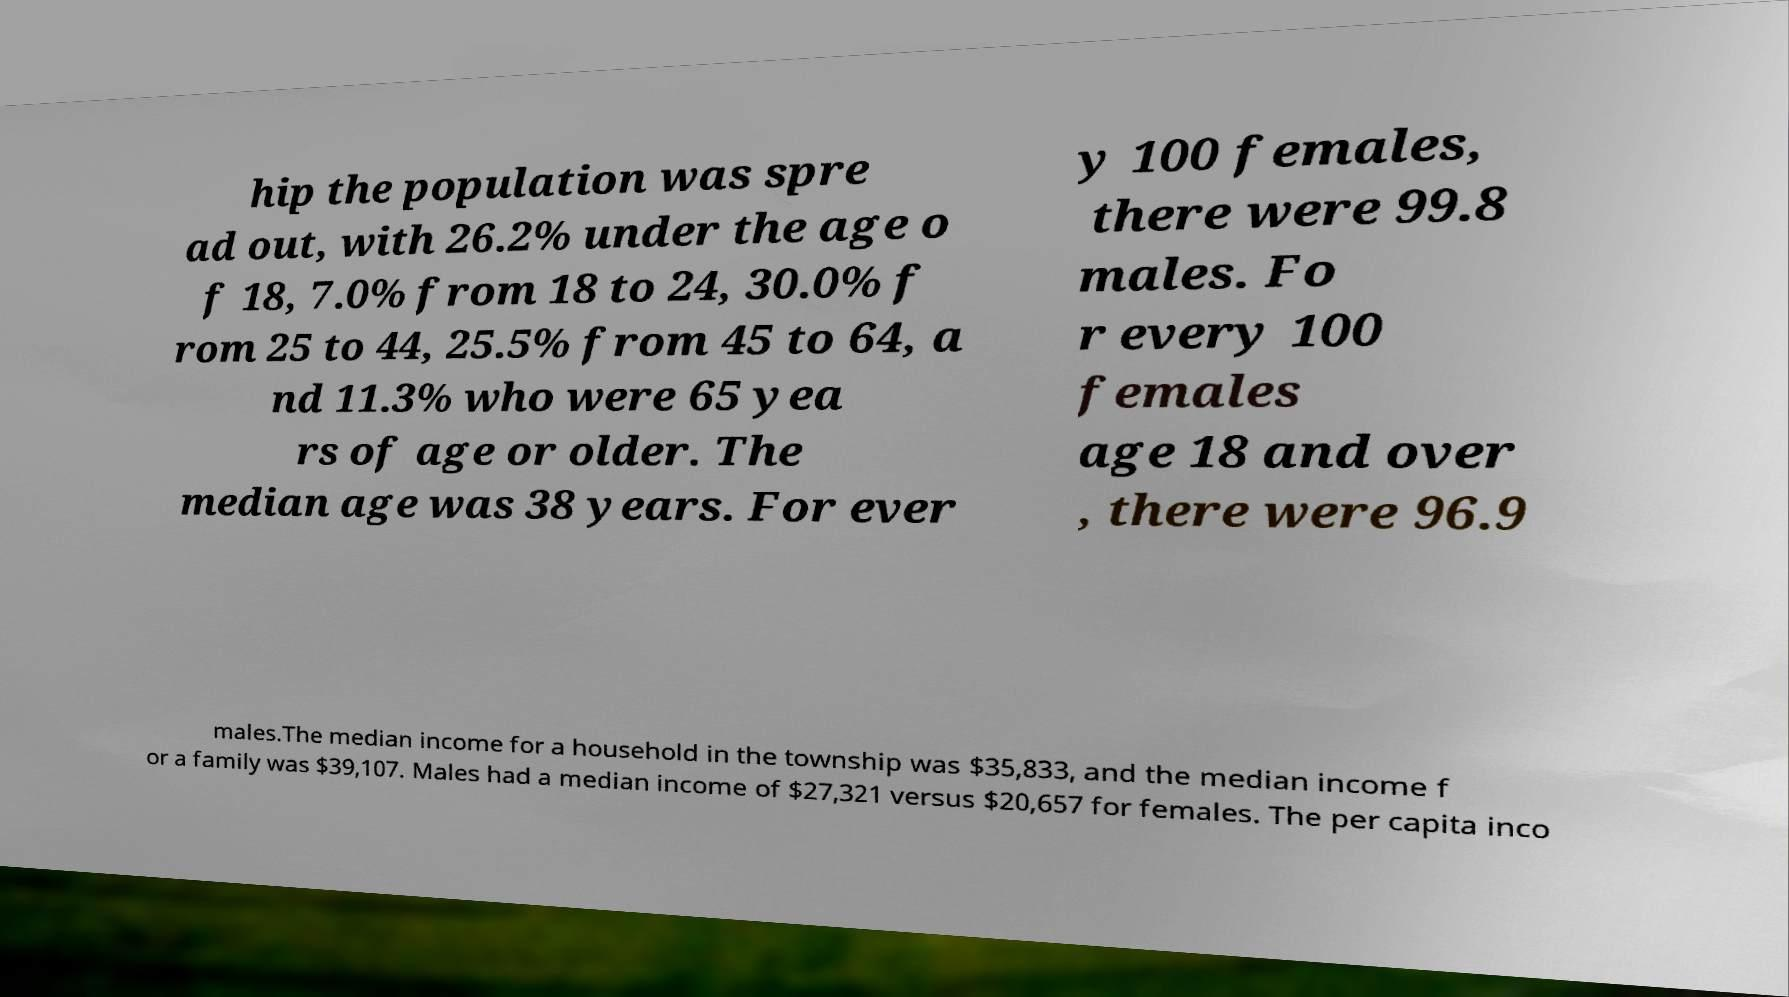There's text embedded in this image that I need extracted. Can you transcribe it verbatim? hip the population was spre ad out, with 26.2% under the age o f 18, 7.0% from 18 to 24, 30.0% f rom 25 to 44, 25.5% from 45 to 64, a nd 11.3% who were 65 yea rs of age or older. The median age was 38 years. For ever y 100 females, there were 99.8 males. Fo r every 100 females age 18 and over , there were 96.9 males.The median income for a household in the township was $35,833, and the median income f or a family was $39,107. Males had a median income of $27,321 versus $20,657 for females. The per capita inco 